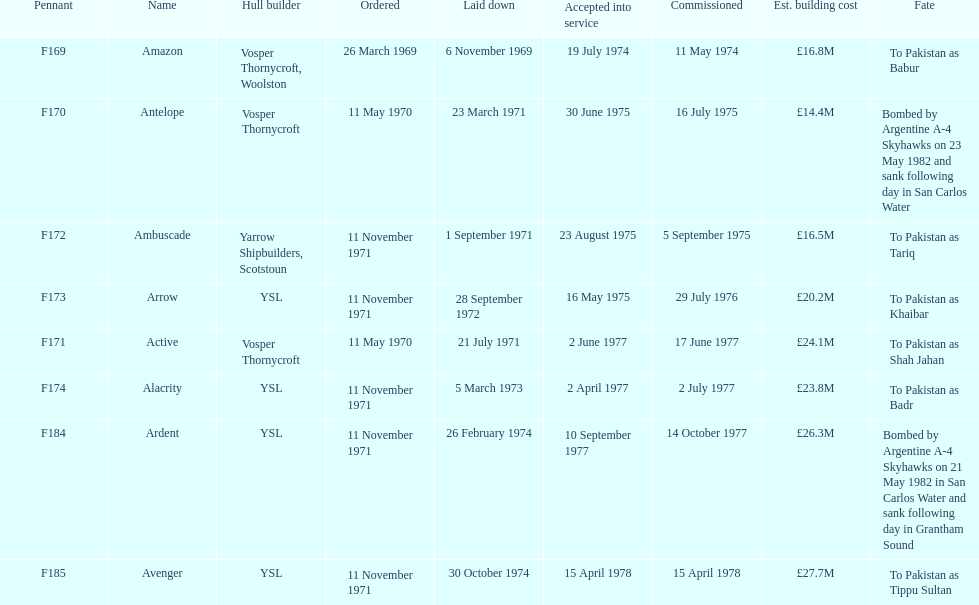How many ships were laid down in september? 2. 